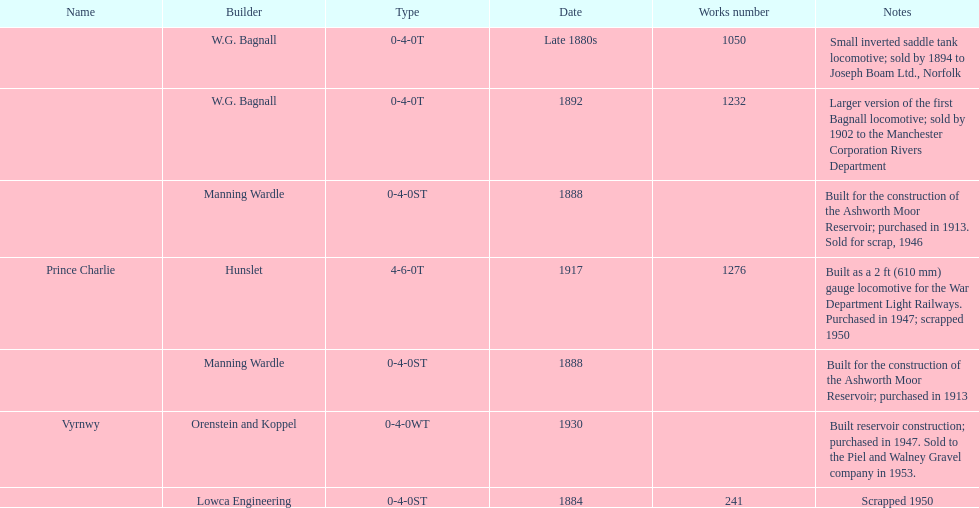Who built the larger version of the first bagnall locomotive? W.G. Bagnall. 